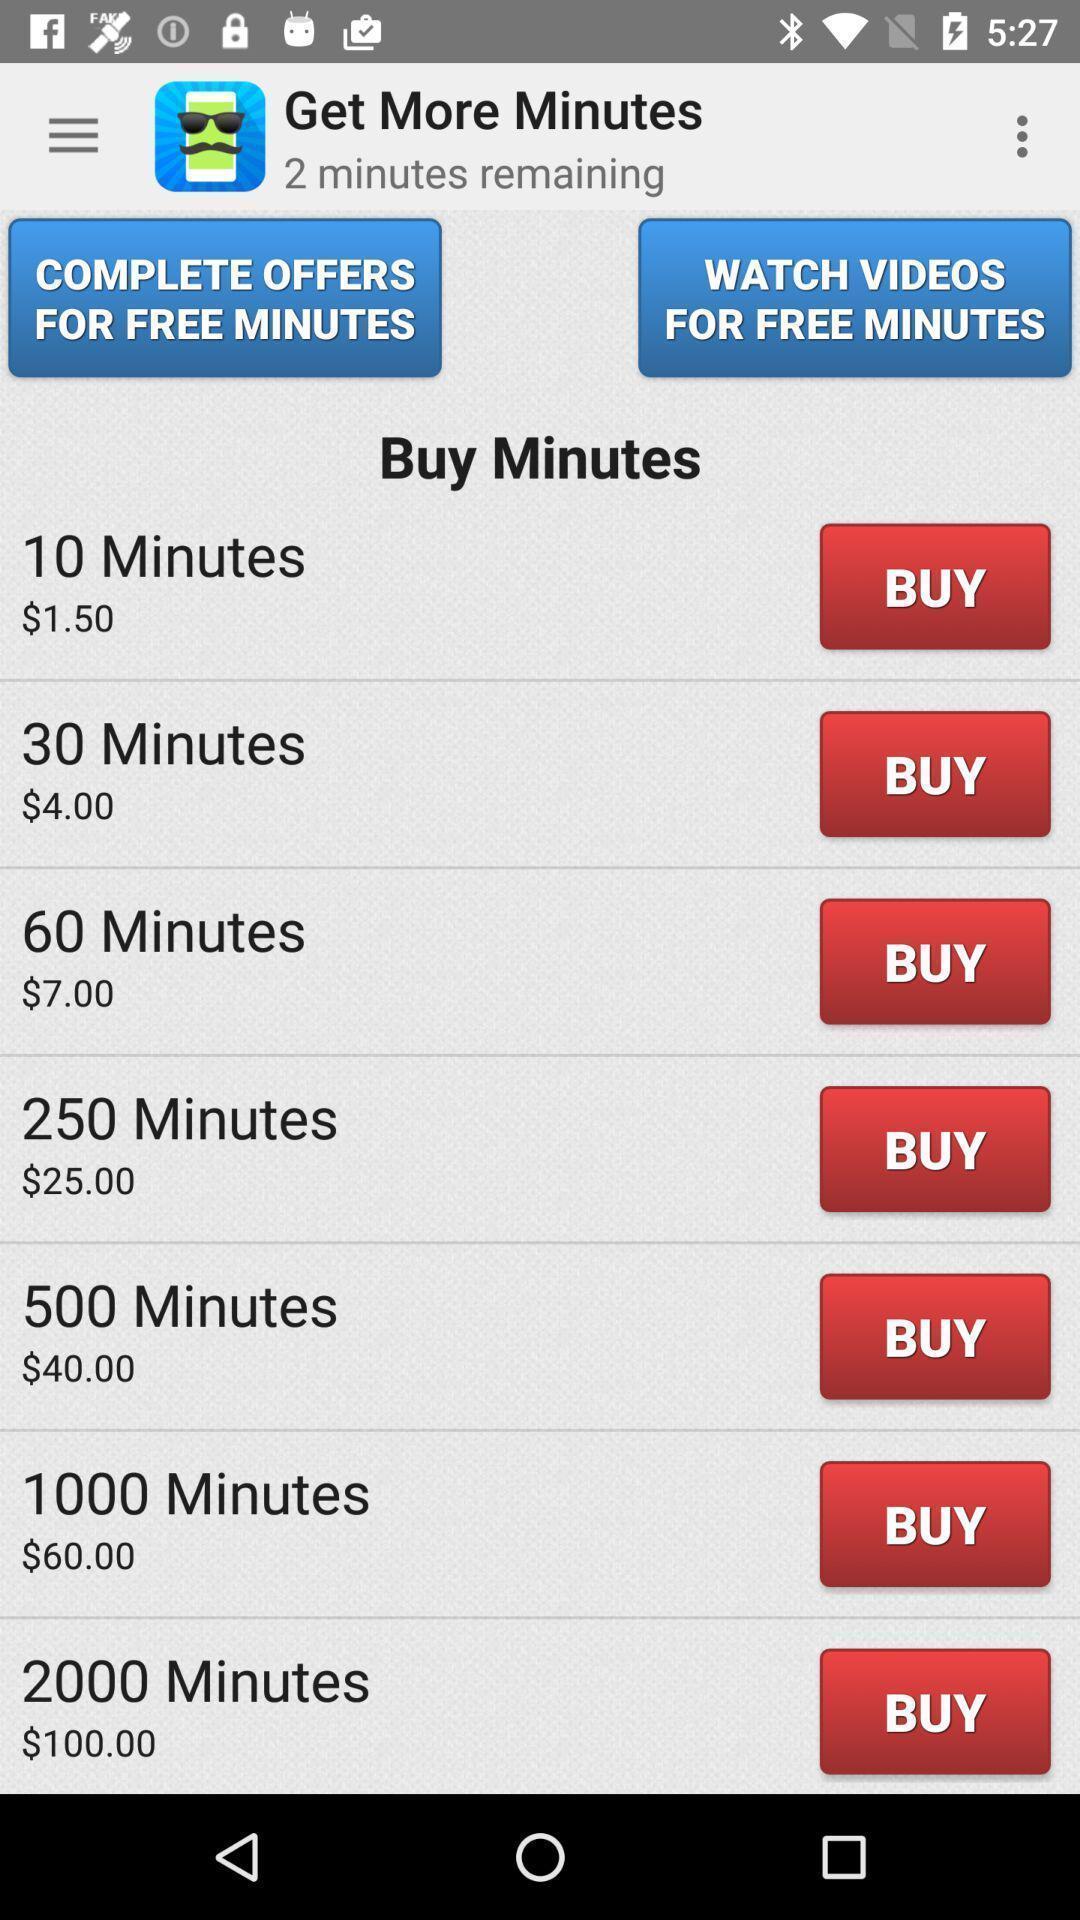What is the overall content of this screenshot? Screen displaying options to buy minutes. 